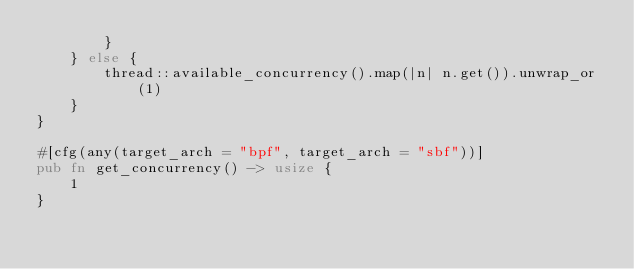Convert code to text. <code><loc_0><loc_0><loc_500><loc_500><_Rust_>        }
    } else {
        thread::available_concurrency().map(|n| n.get()).unwrap_or(1)
    }
}

#[cfg(any(target_arch = "bpf", target_arch = "sbf"))]
pub fn get_concurrency() -> usize {
    1
}
</code> 